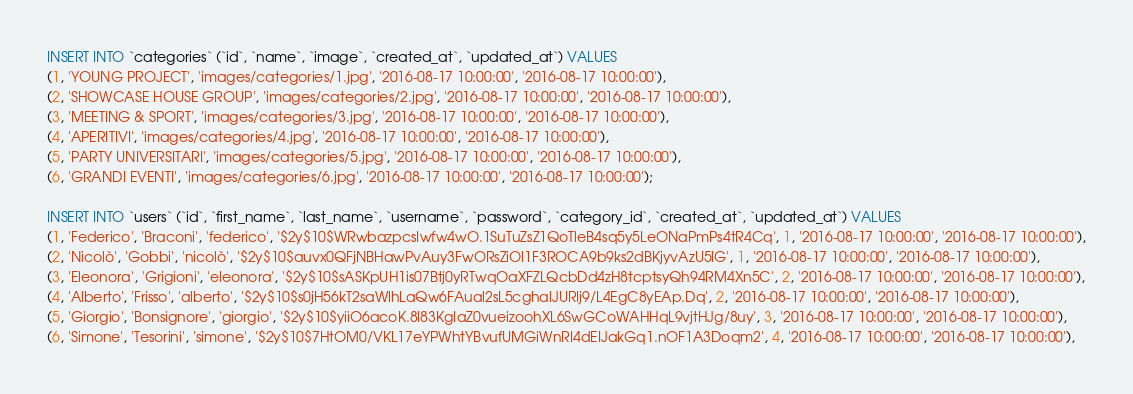<code> <loc_0><loc_0><loc_500><loc_500><_SQL_>INSERT INTO `categories` (`id`, `name`, `image`, `created_at`, `updated_at`) VALUES
(1, 'YOUNG PROJECT', 'images/categories/1.jpg', '2016-08-17 10:00:00', '2016-08-17 10:00:00'),
(2, 'SHOWCASE HOUSE GROUP', 'images/categories/2.jpg', '2016-08-17 10:00:00', '2016-08-17 10:00:00'),
(3, 'MEETING & SPORT', 'images/categories/3.jpg', '2016-08-17 10:00:00', '2016-08-17 10:00:00'),
(4, 'APERITIVI', 'images/categories/4.jpg', '2016-08-17 10:00:00', '2016-08-17 10:00:00'),
(5, 'PARTY UNIVERSITARI', 'images/categories/5.jpg', '2016-08-17 10:00:00', '2016-08-17 10:00:00'),
(6, 'GRANDI EVENTI', 'images/categories/6.jpg', '2016-08-17 10:00:00', '2016-08-17 10:00:00');

INSERT INTO `users` (`id`, `first_name`, `last_name`, `username`, `password`, `category_id`, `created_at`, `updated_at`) VALUES
(1, 'Federico', 'Braconi', 'federico', '$2y$10$WRwbazpcsIwfw4wO.1SuTuZsZ1QoTleB4sq5y5LeONaPmPs4tR4Cq', 1, '2016-08-17 10:00:00', '2016-08-17 10:00:00'),
(2, 'Nicolò', 'Gobbi', 'nicolò', '$2y$10$auvx0QFjNBHawPvAuy3FwORsZiOl1F3ROCA9b9ks2dBKjyvAzU5lG', 1, '2016-08-17 10:00:00', '2016-08-17 10:00:00'),
(3, 'Eleonora', 'Grigioni', 'eleonora', '$2y$10$sASKpUH1is07Btj0yRTwqOaXFZLQcbDd4zH8tcptsyQh94RM4Xn5C', 2, '2016-08-17 10:00:00', '2016-08-17 10:00:00'),
(4, 'Alberto', 'Frisso', 'alberto', '$2y$10$s0jH56kT2saWlhLaQw6FAual2sL5cghalJURIj9/L4EgC8yEAp.Dq', 2, '2016-08-17 10:00:00', '2016-08-17 10:00:00'),
(5, 'Giorgio', 'Bonsignore', 'giorgio', '$2y$10$yiiO6acoK.8l83KgIaZ0vueizoohXL6SwGCoWAHHqL9vjtHJg/8uy', 3, '2016-08-17 10:00:00', '2016-08-17 10:00:00'),
(6, 'Simone', 'Tesorini', 'simone', '$2y$10$7HtOM0/VKL17eYPWhtYBvufUMGiWnRI4dEIJakGq1.nOF1A3Doqm2', 4, '2016-08-17 10:00:00', '2016-08-17 10:00:00'),</code> 